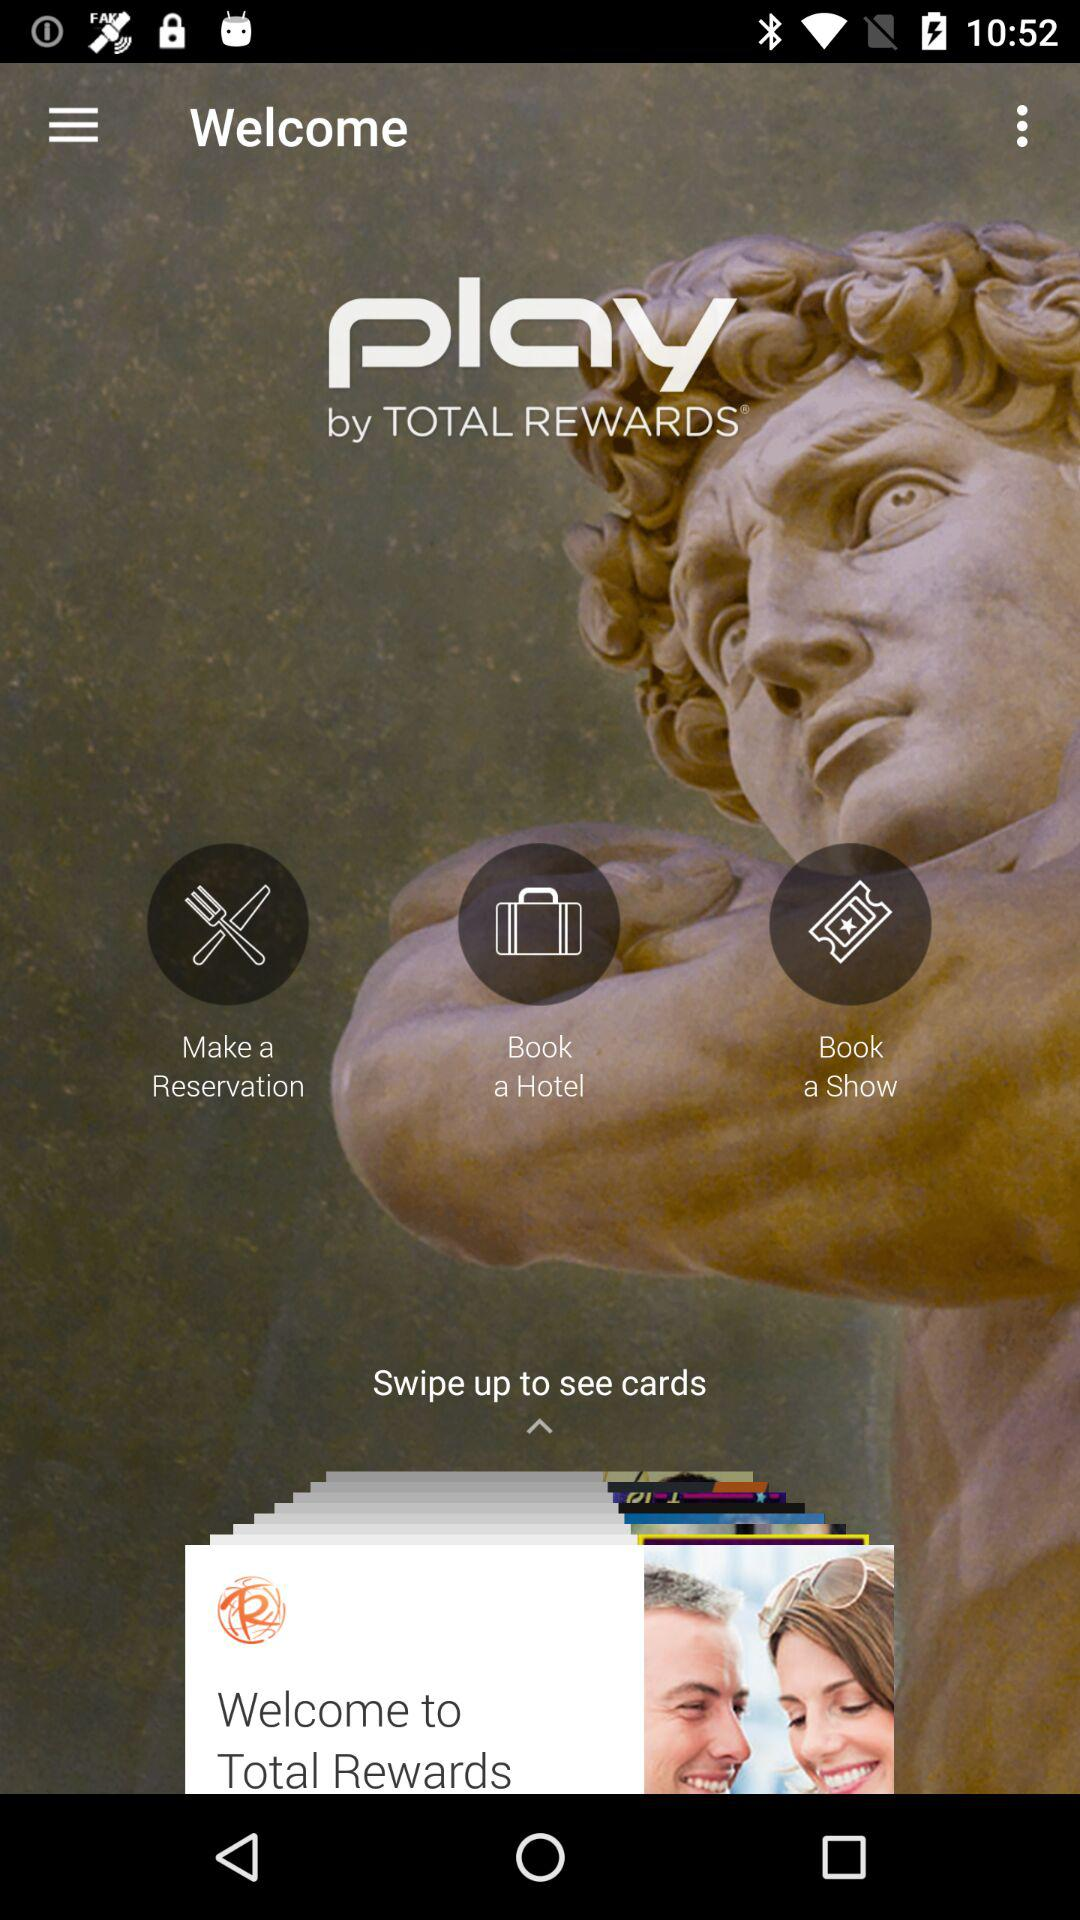What is the app name? The app name is "play". 